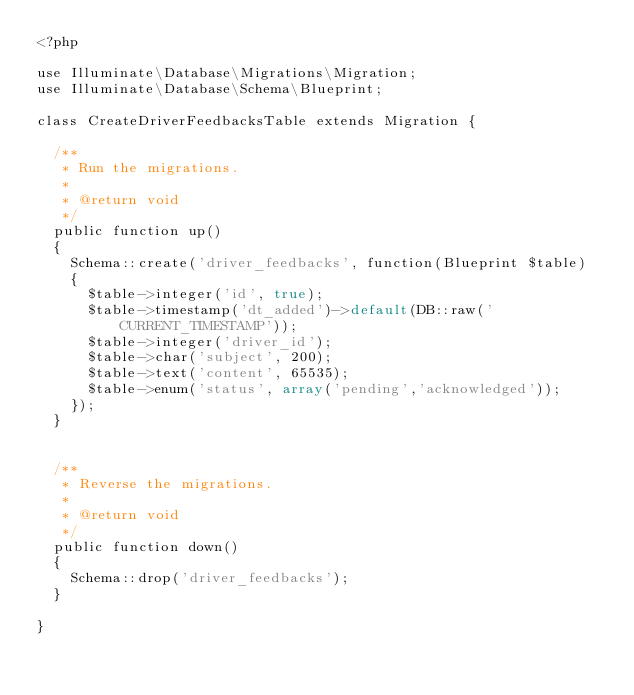Convert code to text. <code><loc_0><loc_0><loc_500><loc_500><_PHP_><?php

use Illuminate\Database\Migrations\Migration;
use Illuminate\Database\Schema\Blueprint;

class CreateDriverFeedbacksTable extends Migration {

	/**
	 * Run the migrations.
	 *
	 * @return void
	 */
	public function up()
	{
		Schema::create('driver_feedbacks', function(Blueprint $table)
		{
			$table->integer('id', true);
			$table->timestamp('dt_added')->default(DB::raw('CURRENT_TIMESTAMP'));
			$table->integer('driver_id');
			$table->char('subject', 200);
			$table->text('content', 65535);
			$table->enum('status', array('pending','acknowledged'));
		});
	}


	/**
	 * Reverse the migrations.
	 *
	 * @return void
	 */
	public function down()
	{
		Schema::drop('driver_feedbacks');
	}

}
</code> 